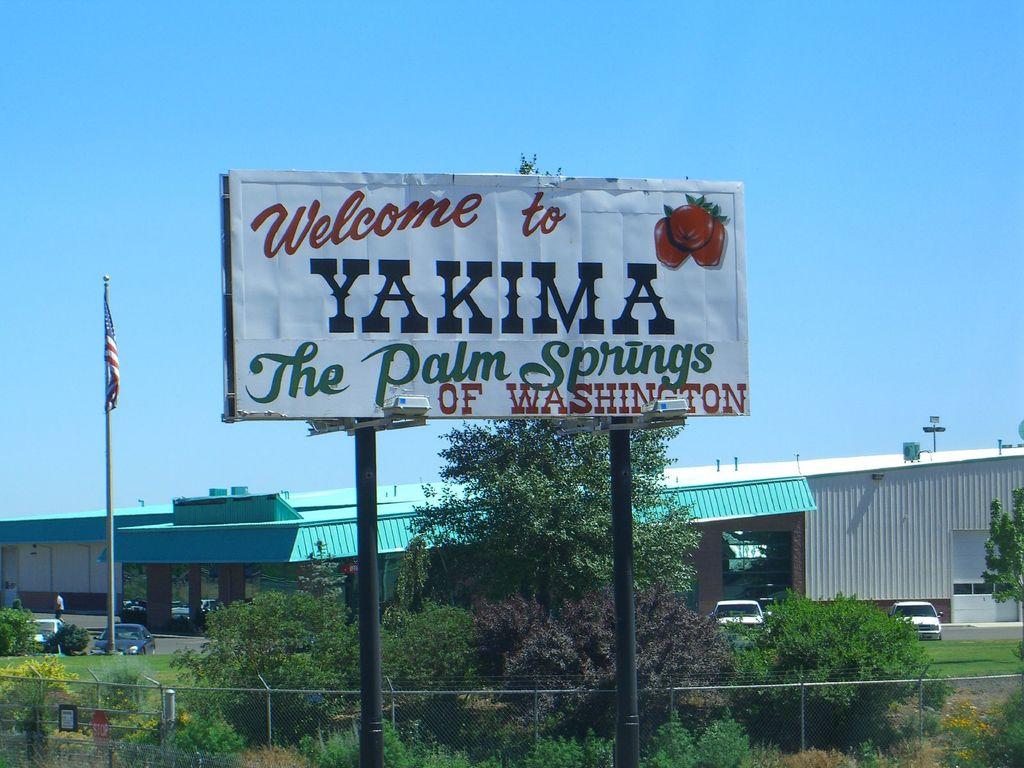Where is this sign being posted?
Offer a very short reply. Yakima. 